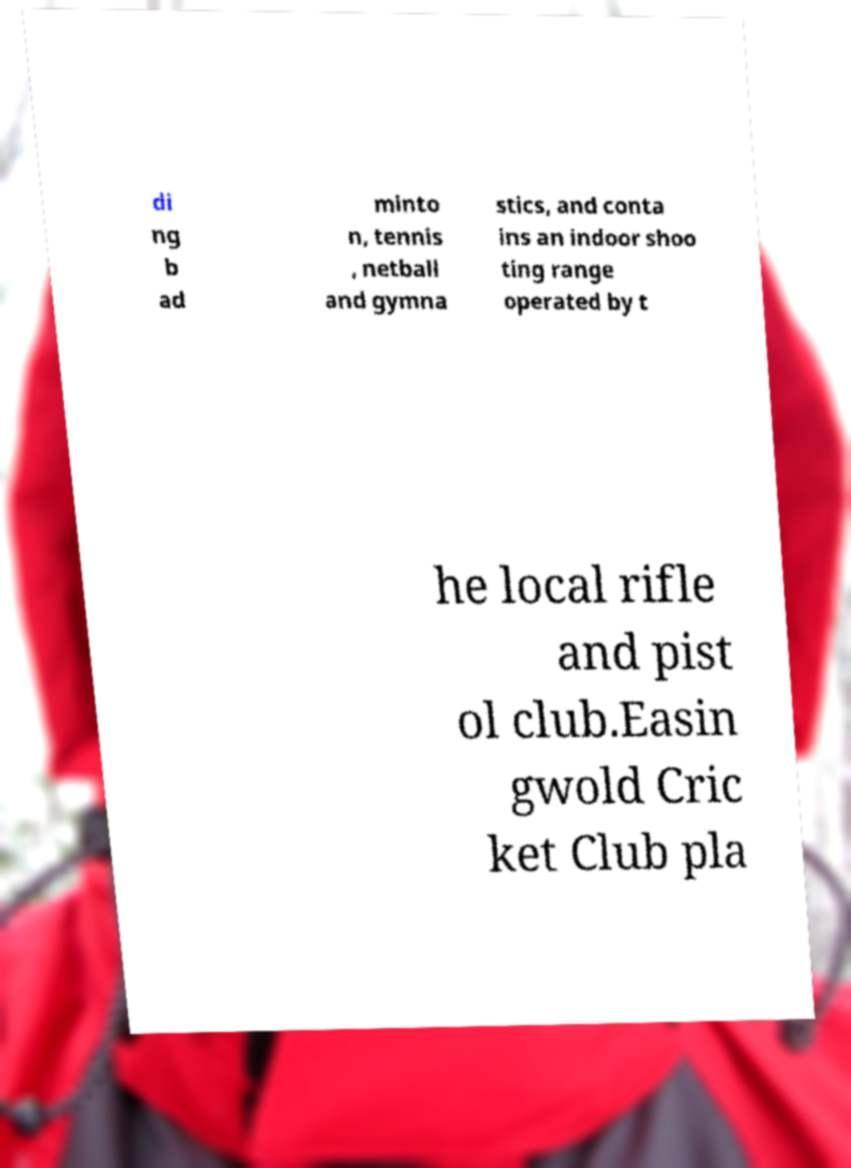I need the written content from this picture converted into text. Can you do that? di ng b ad minto n, tennis , netball and gymna stics, and conta ins an indoor shoo ting range operated by t he local rifle and pist ol club.Easin gwold Cric ket Club pla 